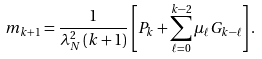Convert formula to latex. <formula><loc_0><loc_0><loc_500><loc_500>m _ { k + 1 } = \frac { 1 } { \lambda _ { N } ^ { 2 } \left ( k + 1 \right ) } \left [ P _ { k } + \sum _ { \ell = 0 } ^ { k - 2 } \mu _ { \ell } G _ { k - \ell } \right ] .</formula> 